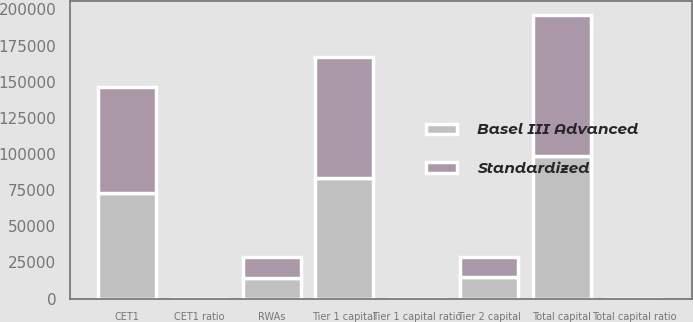Convert chart to OTSL. <chart><loc_0><loc_0><loc_500><loc_500><stacked_bar_chart><ecel><fcel>CET1<fcel>Tier 1 capital<fcel>Tier 2 capital<fcel>Total capital<fcel>RWAs<fcel>CET1 ratio<fcel>Tier 1 capital ratio<fcel>Total capital ratio<nl><fcel>Basel III Advanced<fcel>73116<fcel>83702<fcel>14926<fcel>98628<fcel>14334.5<fcel>13.3<fcel>15.3<fcel>18<nl><fcel>Standardized<fcel>73116<fcel>83702<fcel>13743<fcel>97445<fcel>14334.5<fcel>13.1<fcel>15<fcel>17.5<nl></chart> 